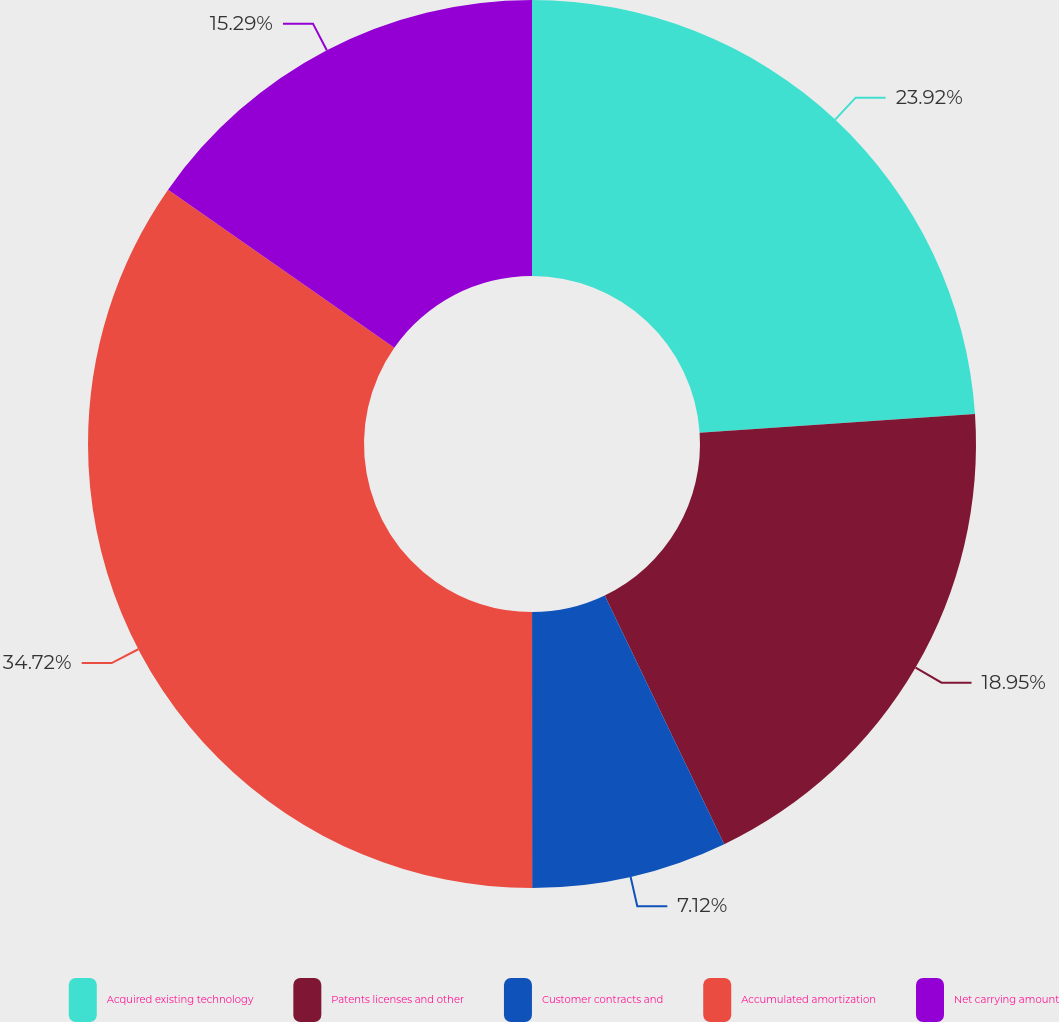Convert chart. <chart><loc_0><loc_0><loc_500><loc_500><pie_chart><fcel>Acquired existing technology<fcel>Patents licenses and other<fcel>Customer contracts and<fcel>Accumulated amortization<fcel>Net carrying amount<nl><fcel>23.92%<fcel>18.95%<fcel>7.12%<fcel>34.71%<fcel>15.29%<nl></chart> 